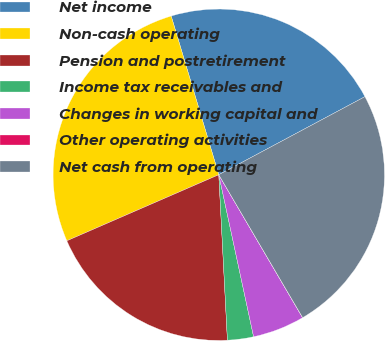<chart> <loc_0><loc_0><loc_500><loc_500><pie_chart><fcel>Net income<fcel>Non-cash operating<fcel>Pension and postretirement<fcel>Income tax receivables and<fcel>Changes in working capital and<fcel>Other operating activities<fcel>Net cash from operating<nl><fcel>21.83%<fcel>26.89%<fcel>19.3%<fcel>2.54%<fcel>5.07%<fcel>0.01%<fcel>24.36%<nl></chart> 